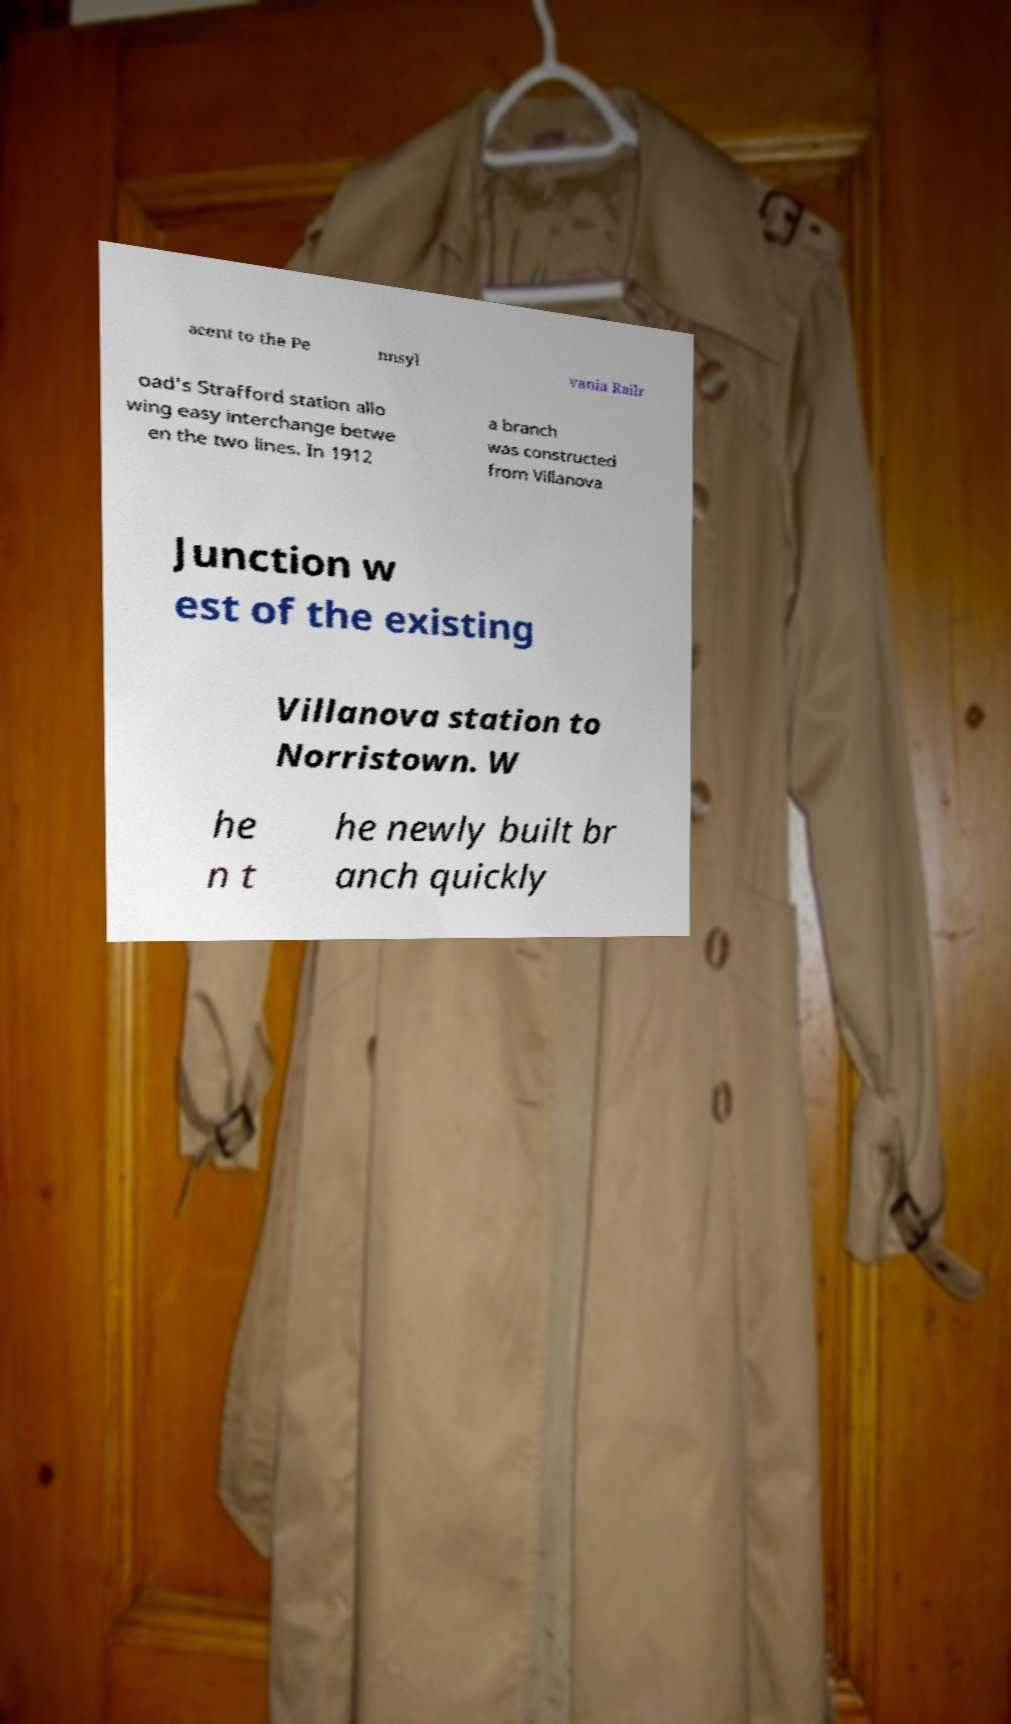Can you read and provide the text displayed in the image?This photo seems to have some interesting text. Can you extract and type it out for me? acent to the Pe nnsyl vania Railr oad's Strafford station allo wing easy interchange betwe en the two lines. In 1912 a branch was constructed from Villanova Junction w est of the existing Villanova station to Norristown. W he n t he newly built br anch quickly 